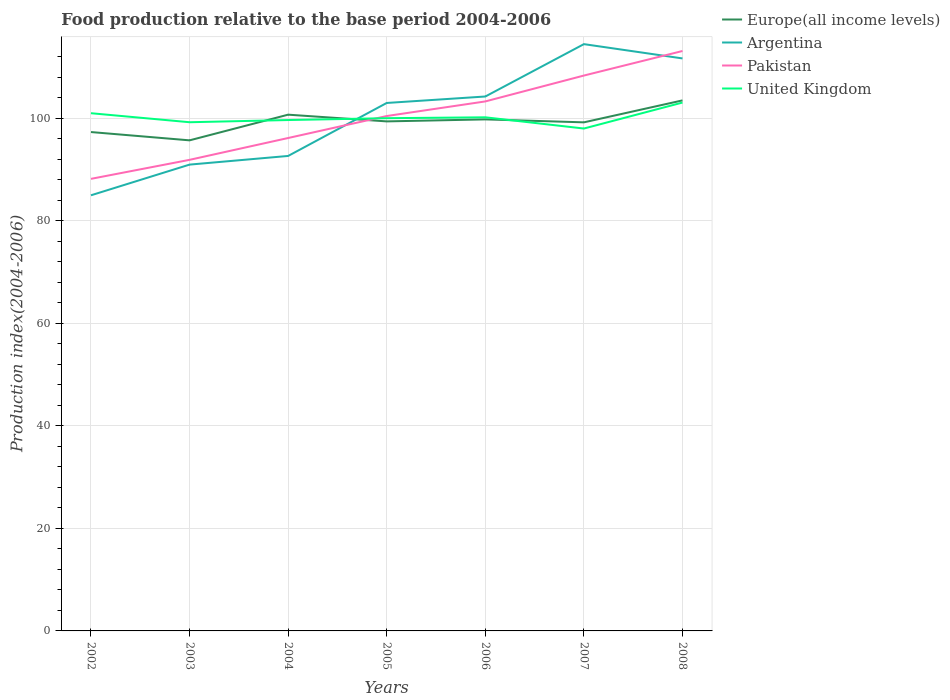How many different coloured lines are there?
Your answer should be compact. 4. Does the line corresponding to Argentina intersect with the line corresponding to United Kingdom?
Provide a succinct answer. Yes. Across all years, what is the maximum food production index in Argentina?
Offer a terse response. 85.01. In which year was the food production index in Europe(all income levels) maximum?
Provide a short and direct response. 2003. What is the total food production index in Pakistan in the graph?
Give a very brief answer. -11.4. What is the difference between the highest and the second highest food production index in Pakistan?
Keep it short and to the point. 24.95. What is the difference between the highest and the lowest food production index in Pakistan?
Make the answer very short. 4. How many lines are there?
Keep it short and to the point. 4. Are the values on the major ticks of Y-axis written in scientific E-notation?
Keep it short and to the point. No. Does the graph contain grids?
Keep it short and to the point. Yes. What is the title of the graph?
Keep it short and to the point. Food production relative to the base period 2004-2006. Does "Peru" appear as one of the legend labels in the graph?
Ensure brevity in your answer.  No. What is the label or title of the X-axis?
Give a very brief answer. Years. What is the label or title of the Y-axis?
Ensure brevity in your answer.  Production index(2004-2006). What is the Production index(2004-2006) in Europe(all income levels) in 2002?
Keep it short and to the point. 97.35. What is the Production index(2004-2006) in Argentina in 2002?
Offer a terse response. 85.01. What is the Production index(2004-2006) of Pakistan in 2002?
Provide a short and direct response. 88.22. What is the Production index(2004-2006) of United Kingdom in 2002?
Your answer should be compact. 101.03. What is the Production index(2004-2006) in Europe(all income levels) in 2003?
Ensure brevity in your answer.  95.74. What is the Production index(2004-2006) of Argentina in 2003?
Your answer should be compact. 91. What is the Production index(2004-2006) of Pakistan in 2003?
Provide a short and direct response. 91.93. What is the Production index(2004-2006) in United Kingdom in 2003?
Your answer should be very brief. 99.27. What is the Production index(2004-2006) in Europe(all income levels) in 2004?
Make the answer very short. 100.75. What is the Production index(2004-2006) of Argentina in 2004?
Ensure brevity in your answer.  92.69. What is the Production index(2004-2006) in Pakistan in 2004?
Offer a terse response. 96.19. What is the Production index(2004-2006) in United Kingdom in 2004?
Make the answer very short. 99.7. What is the Production index(2004-2006) of Europe(all income levels) in 2005?
Make the answer very short. 99.43. What is the Production index(2004-2006) of Argentina in 2005?
Your answer should be compact. 103.03. What is the Production index(2004-2006) of Pakistan in 2005?
Offer a terse response. 100.48. What is the Production index(2004-2006) of United Kingdom in 2005?
Offer a terse response. 100.06. What is the Production index(2004-2006) in Europe(all income levels) in 2006?
Provide a short and direct response. 99.82. What is the Production index(2004-2006) of Argentina in 2006?
Give a very brief answer. 104.29. What is the Production index(2004-2006) of Pakistan in 2006?
Your response must be concise. 103.33. What is the Production index(2004-2006) of United Kingdom in 2006?
Keep it short and to the point. 100.23. What is the Production index(2004-2006) in Europe(all income levels) in 2007?
Make the answer very short. 99.25. What is the Production index(2004-2006) of Argentina in 2007?
Offer a very short reply. 114.51. What is the Production index(2004-2006) of Pakistan in 2007?
Provide a succinct answer. 108.38. What is the Production index(2004-2006) in United Kingdom in 2007?
Your answer should be very brief. 98.04. What is the Production index(2004-2006) of Europe(all income levels) in 2008?
Offer a very short reply. 103.53. What is the Production index(2004-2006) of Argentina in 2008?
Give a very brief answer. 111.72. What is the Production index(2004-2006) of Pakistan in 2008?
Keep it short and to the point. 113.17. What is the Production index(2004-2006) of United Kingdom in 2008?
Ensure brevity in your answer.  103.11. Across all years, what is the maximum Production index(2004-2006) of Europe(all income levels)?
Make the answer very short. 103.53. Across all years, what is the maximum Production index(2004-2006) in Argentina?
Provide a short and direct response. 114.51. Across all years, what is the maximum Production index(2004-2006) of Pakistan?
Your answer should be compact. 113.17. Across all years, what is the maximum Production index(2004-2006) of United Kingdom?
Provide a short and direct response. 103.11. Across all years, what is the minimum Production index(2004-2006) in Europe(all income levels)?
Your response must be concise. 95.74. Across all years, what is the minimum Production index(2004-2006) of Argentina?
Provide a succinct answer. 85.01. Across all years, what is the minimum Production index(2004-2006) of Pakistan?
Your response must be concise. 88.22. Across all years, what is the minimum Production index(2004-2006) of United Kingdom?
Ensure brevity in your answer.  98.04. What is the total Production index(2004-2006) in Europe(all income levels) in the graph?
Your response must be concise. 695.87. What is the total Production index(2004-2006) in Argentina in the graph?
Give a very brief answer. 702.25. What is the total Production index(2004-2006) of Pakistan in the graph?
Make the answer very short. 701.7. What is the total Production index(2004-2006) in United Kingdom in the graph?
Provide a succinct answer. 701.44. What is the difference between the Production index(2004-2006) of Europe(all income levels) in 2002 and that in 2003?
Your answer should be compact. 1.62. What is the difference between the Production index(2004-2006) of Argentina in 2002 and that in 2003?
Offer a very short reply. -5.99. What is the difference between the Production index(2004-2006) of Pakistan in 2002 and that in 2003?
Your answer should be compact. -3.71. What is the difference between the Production index(2004-2006) in United Kingdom in 2002 and that in 2003?
Make the answer very short. 1.76. What is the difference between the Production index(2004-2006) of Europe(all income levels) in 2002 and that in 2004?
Provide a succinct answer. -3.39. What is the difference between the Production index(2004-2006) in Argentina in 2002 and that in 2004?
Give a very brief answer. -7.68. What is the difference between the Production index(2004-2006) in Pakistan in 2002 and that in 2004?
Offer a very short reply. -7.97. What is the difference between the Production index(2004-2006) in United Kingdom in 2002 and that in 2004?
Keep it short and to the point. 1.33. What is the difference between the Production index(2004-2006) in Europe(all income levels) in 2002 and that in 2005?
Your response must be concise. -2.08. What is the difference between the Production index(2004-2006) of Argentina in 2002 and that in 2005?
Your answer should be compact. -18.02. What is the difference between the Production index(2004-2006) of Pakistan in 2002 and that in 2005?
Ensure brevity in your answer.  -12.26. What is the difference between the Production index(2004-2006) of United Kingdom in 2002 and that in 2005?
Provide a succinct answer. 0.97. What is the difference between the Production index(2004-2006) in Europe(all income levels) in 2002 and that in 2006?
Offer a terse response. -2.47. What is the difference between the Production index(2004-2006) of Argentina in 2002 and that in 2006?
Give a very brief answer. -19.28. What is the difference between the Production index(2004-2006) of Pakistan in 2002 and that in 2006?
Keep it short and to the point. -15.11. What is the difference between the Production index(2004-2006) of Europe(all income levels) in 2002 and that in 2007?
Offer a terse response. -1.9. What is the difference between the Production index(2004-2006) of Argentina in 2002 and that in 2007?
Your answer should be compact. -29.5. What is the difference between the Production index(2004-2006) in Pakistan in 2002 and that in 2007?
Offer a terse response. -20.16. What is the difference between the Production index(2004-2006) of United Kingdom in 2002 and that in 2007?
Provide a succinct answer. 2.99. What is the difference between the Production index(2004-2006) in Europe(all income levels) in 2002 and that in 2008?
Provide a succinct answer. -6.18. What is the difference between the Production index(2004-2006) of Argentina in 2002 and that in 2008?
Offer a terse response. -26.71. What is the difference between the Production index(2004-2006) in Pakistan in 2002 and that in 2008?
Your answer should be very brief. -24.95. What is the difference between the Production index(2004-2006) of United Kingdom in 2002 and that in 2008?
Offer a terse response. -2.08. What is the difference between the Production index(2004-2006) of Europe(all income levels) in 2003 and that in 2004?
Offer a very short reply. -5.01. What is the difference between the Production index(2004-2006) of Argentina in 2003 and that in 2004?
Offer a terse response. -1.69. What is the difference between the Production index(2004-2006) of Pakistan in 2003 and that in 2004?
Your answer should be compact. -4.26. What is the difference between the Production index(2004-2006) of United Kingdom in 2003 and that in 2004?
Offer a terse response. -0.43. What is the difference between the Production index(2004-2006) in Europe(all income levels) in 2003 and that in 2005?
Keep it short and to the point. -3.7. What is the difference between the Production index(2004-2006) of Argentina in 2003 and that in 2005?
Provide a short and direct response. -12.03. What is the difference between the Production index(2004-2006) in Pakistan in 2003 and that in 2005?
Provide a short and direct response. -8.55. What is the difference between the Production index(2004-2006) of United Kingdom in 2003 and that in 2005?
Your answer should be compact. -0.79. What is the difference between the Production index(2004-2006) of Europe(all income levels) in 2003 and that in 2006?
Your answer should be very brief. -4.09. What is the difference between the Production index(2004-2006) of Argentina in 2003 and that in 2006?
Ensure brevity in your answer.  -13.29. What is the difference between the Production index(2004-2006) of Pakistan in 2003 and that in 2006?
Your response must be concise. -11.4. What is the difference between the Production index(2004-2006) in United Kingdom in 2003 and that in 2006?
Provide a short and direct response. -0.96. What is the difference between the Production index(2004-2006) in Europe(all income levels) in 2003 and that in 2007?
Offer a terse response. -3.51. What is the difference between the Production index(2004-2006) in Argentina in 2003 and that in 2007?
Provide a succinct answer. -23.51. What is the difference between the Production index(2004-2006) in Pakistan in 2003 and that in 2007?
Make the answer very short. -16.45. What is the difference between the Production index(2004-2006) in United Kingdom in 2003 and that in 2007?
Your response must be concise. 1.23. What is the difference between the Production index(2004-2006) in Europe(all income levels) in 2003 and that in 2008?
Your answer should be very brief. -7.8. What is the difference between the Production index(2004-2006) of Argentina in 2003 and that in 2008?
Provide a short and direct response. -20.72. What is the difference between the Production index(2004-2006) of Pakistan in 2003 and that in 2008?
Make the answer very short. -21.24. What is the difference between the Production index(2004-2006) in United Kingdom in 2003 and that in 2008?
Provide a short and direct response. -3.84. What is the difference between the Production index(2004-2006) of Europe(all income levels) in 2004 and that in 2005?
Make the answer very short. 1.31. What is the difference between the Production index(2004-2006) of Argentina in 2004 and that in 2005?
Make the answer very short. -10.34. What is the difference between the Production index(2004-2006) of Pakistan in 2004 and that in 2005?
Give a very brief answer. -4.29. What is the difference between the Production index(2004-2006) in United Kingdom in 2004 and that in 2005?
Your response must be concise. -0.36. What is the difference between the Production index(2004-2006) in Europe(all income levels) in 2004 and that in 2006?
Your answer should be very brief. 0.92. What is the difference between the Production index(2004-2006) of Argentina in 2004 and that in 2006?
Provide a succinct answer. -11.6. What is the difference between the Production index(2004-2006) in Pakistan in 2004 and that in 2006?
Keep it short and to the point. -7.14. What is the difference between the Production index(2004-2006) in United Kingdom in 2004 and that in 2006?
Provide a short and direct response. -0.53. What is the difference between the Production index(2004-2006) of Europe(all income levels) in 2004 and that in 2007?
Your answer should be compact. 1.5. What is the difference between the Production index(2004-2006) of Argentina in 2004 and that in 2007?
Offer a very short reply. -21.82. What is the difference between the Production index(2004-2006) of Pakistan in 2004 and that in 2007?
Offer a terse response. -12.19. What is the difference between the Production index(2004-2006) in United Kingdom in 2004 and that in 2007?
Provide a short and direct response. 1.66. What is the difference between the Production index(2004-2006) of Europe(all income levels) in 2004 and that in 2008?
Your answer should be compact. -2.79. What is the difference between the Production index(2004-2006) in Argentina in 2004 and that in 2008?
Offer a terse response. -19.03. What is the difference between the Production index(2004-2006) in Pakistan in 2004 and that in 2008?
Offer a terse response. -16.98. What is the difference between the Production index(2004-2006) of United Kingdom in 2004 and that in 2008?
Your response must be concise. -3.41. What is the difference between the Production index(2004-2006) of Europe(all income levels) in 2005 and that in 2006?
Provide a short and direct response. -0.39. What is the difference between the Production index(2004-2006) in Argentina in 2005 and that in 2006?
Make the answer very short. -1.26. What is the difference between the Production index(2004-2006) in Pakistan in 2005 and that in 2006?
Ensure brevity in your answer.  -2.85. What is the difference between the Production index(2004-2006) of United Kingdom in 2005 and that in 2006?
Your answer should be very brief. -0.17. What is the difference between the Production index(2004-2006) of Europe(all income levels) in 2005 and that in 2007?
Give a very brief answer. 0.19. What is the difference between the Production index(2004-2006) in Argentina in 2005 and that in 2007?
Provide a short and direct response. -11.48. What is the difference between the Production index(2004-2006) of Pakistan in 2005 and that in 2007?
Your answer should be compact. -7.9. What is the difference between the Production index(2004-2006) of United Kingdom in 2005 and that in 2007?
Your response must be concise. 2.02. What is the difference between the Production index(2004-2006) in Europe(all income levels) in 2005 and that in 2008?
Offer a terse response. -4.1. What is the difference between the Production index(2004-2006) in Argentina in 2005 and that in 2008?
Make the answer very short. -8.69. What is the difference between the Production index(2004-2006) of Pakistan in 2005 and that in 2008?
Your response must be concise. -12.69. What is the difference between the Production index(2004-2006) of United Kingdom in 2005 and that in 2008?
Offer a very short reply. -3.05. What is the difference between the Production index(2004-2006) in Europe(all income levels) in 2006 and that in 2007?
Your answer should be very brief. 0.57. What is the difference between the Production index(2004-2006) of Argentina in 2006 and that in 2007?
Keep it short and to the point. -10.22. What is the difference between the Production index(2004-2006) in Pakistan in 2006 and that in 2007?
Offer a terse response. -5.05. What is the difference between the Production index(2004-2006) of United Kingdom in 2006 and that in 2007?
Your answer should be compact. 2.19. What is the difference between the Production index(2004-2006) of Europe(all income levels) in 2006 and that in 2008?
Provide a short and direct response. -3.71. What is the difference between the Production index(2004-2006) of Argentina in 2006 and that in 2008?
Offer a very short reply. -7.43. What is the difference between the Production index(2004-2006) in Pakistan in 2006 and that in 2008?
Keep it short and to the point. -9.84. What is the difference between the Production index(2004-2006) in United Kingdom in 2006 and that in 2008?
Offer a very short reply. -2.88. What is the difference between the Production index(2004-2006) of Europe(all income levels) in 2007 and that in 2008?
Ensure brevity in your answer.  -4.28. What is the difference between the Production index(2004-2006) of Argentina in 2007 and that in 2008?
Keep it short and to the point. 2.79. What is the difference between the Production index(2004-2006) in Pakistan in 2007 and that in 2008?
Offer a very short reply. -4.79. What is the difference between the Production index(2004-2006) of United Kingdom in 2007 and that in 2008?
Keep it short and to the point. -5.07. What is the difference between the Production index(2004-2006) of Europe(all income levels) in 2002 and the Production index(2004-2006) of Argentina in 2003?
Keep it short and to the point. 6.35. What is the difference between the Production index(2004-2006) in Europe(all income levels) in 2002 and the Production index(2004-2006) in Pakistan in 2003?
Offer a very short reply. 5.42. What is the difference between the Production index(2004-2006) in Europe(all income levels) in 2002 and the Production index(2004-2006) in United Kingdom in 2003?
Offer a very short reply. -1.92. What is the difference between the Production index(2004-2006) of Argentina in 2002 and the Production index(2004-2006) of Pakistan in 2003?
Offer a terse response. -6.92. What is the difference between the Production index(2004-2006) of Argentina in 2002 and the Production index(2004-2006) of United Kingdom in 2003?
Offer a very short reply. -14.26. What is the difference between the Production index(2004-2006) in Pakistan in 2002 and the Production index(2004-2006) in United Kingdom in 2003?
Your response must be concise. -11.05. What is the difference between the Production index(2004-2006) of Europe(all income levels) in 2002 and the Production index(2004-2006) of Argentina in 2004?
Make the answer very short. 4.66. What is the difference between the Production index(2004-2006) of Europe(all income levels) in 2002 and the Production index(2004-2006) of Pakistan in 2004?
Provide a short and direct response. 1.16. What is the difference between the Production index(2004-2006) in Europe(all income levels) in 2002 and the Production index(2004-2006) in United Kingdom in 2004?
Give a very brief answer. -2.35. What is the difference between the Production index(2004-2006) in Argentina in 2002 and the Production index(2004-2006) in Pakistan in 2004?
Your answer should be very brief. -11.18. What is the difference between the Production index(2004-2006) in Argentina in 2002 and the Production index(2004-2006) in United Kingdom in 2004?
Offer a very short reply. -14.69. What is the difference between the Production index(2004-2006) of Pakistan in 2002 and the Production index(2004-2006) of United Kingdom in 2004?
Your answer should be very brief. -11.48. What is the difference between the Production index(2004-2006) in Europe(all income levels) in 2002 and the Production index(2004-2006) in Argentina in 2005?
Your response must be concise. -5.68. What is the difference between the Production index(2004-2006) of Europe(all income levels) in 2002 and the Production index(2004-2006) of Pakistan in 2005?
Your response must be concise. -3.13. What is the difference between the Production index(2004-2006) of Europe(all income levels) in 2002 and the Production index(2004-2006) of United Kingdom in 2005?
Offer a very short reply. -2.71. What is the difference between the Production index(2004-2006) of Argentina in 2002 and the Production index(2004-2006) of Pakistan in 2005?
Give a very brief answer. -15.47. What is the difference between the Production index(2004-2006) in Argentina in 2002 and the Production index(2004-2006) in United Kingdom in 2005?
Your answer should be compact. -15.05. What is the difference between the Production index(2004-2006) in Pakistan in 2002 and the Production index(2004-2006) in United Kingdom in 2005?
Your answer should be very brief. -11.84. What is the difference between the Production index(2004-2006) in Europe(all income levels) in 2002 and the Production index(2004-2006) in Argentina in 2006?
Offer a terse response. -6.94. What is the difference between the Production index(2004-2006) of Europe(all income levels) in 2002 and the Production index(2004-2006) of Pakistan in 2006?
Give a very brief answer. -5.98. What is the difference between the Production index(2004-2006) in Europe(all income levels) in 2002 and the Production index(2004-2006) in United Kingdom in 2006?
Make the answer very short. -2.88. What is the difference between the Production index(2004-2006) in Argentina in 2002 and the Production index(2004-2006) in Pakistan in 2006?
Offer a very short reply. -18.32. What is the difference between the Production index(2004-2006) in Argentina in 2002 and the Production index(2004-2006) in United Kingdom in 2006?
Your response must be concise. -15.22. What is the difference between the Production index(2004-2006) in Pakistan in 2002 and the Production index(2004-2006) in United Kingdom in 2006?
Provide a short and direct response. -12.01. What is the difference between the Production index(2004-2006) in Europe(all income levels) in 2002 and the Production index(2004-2006) in Argentina in 2007?
Ensure brevity in your answer.  -17.16. What is the difference between the Production index(2004-2006) of Europe(all income levels) in 2002 and the Production index(2004-2006) of Pakistan in 2007?
Ensure brevity in your answer.  -11.03. What is the difference between the Production index(2004-2006) of Europe(all income levels) in 2002 and the Production index(2004-2006) of United Kingdom in 2007?
Give a very brief answer. -0.69. What is the difference between the Production index(2004-2006) of Argentina in 2002 and the Production index(2004-2006) of Pakistan in 2007?
Provide a succinct answer. -23.37. What is the difference between the Production index(2004-2006) in Argentina in 2002 and the Production index(2004-2006) in United Kingdom in 2007?
Keep it short and to the point. -13.03. What is the difference between the Production index(2004-2006) of Pakistan in 2002 and the Production index(2004-2006) of United Kingdom in 2007?
Ensure brevity in your answer.  -9.82. What is the difference between the Production index(2004-2006) of Europe(all income levels) in 2002 and the Production index(2004-2006) of Argentina in 2008?
Your answer should be very brief. -14.37. What is the difference between the Production index(2004-2006) of Europe(all income levels) in 2002 and the Production index(2004-2006) of Pakistan in 2008?
Keep it short and to the point. -15.82. What is the difference between the Production index(2004-2006) of Europe(all income levels) in 2002 and the Production index(2004-2006) of United Kingdom in 2008?
Make the answer very short. -5.76. What is the difference between the Production index(2004-2006) of Argentina in 2002 and the Production index(2004-2006) of Pakistan in 2008?
Keep it short and to the point. -28.16. What is the difference between the Production index(2004-2006) of Argentina in 2002 and the Production index(2004-2006) of United Kingdom in 2008?
Provide a short and direct response. -18.1. What is the difference between the Production index(2004-2006) in Pakistan in 2002 and the Production index(2004-2006) in United Kingdom in 2008?
Offer a terse response. -14.89. What is the difference between the Production index(2004-2006) of Europe(all income levels) in 2003 and the Production index(2004-2006) of Argentina in 2004?
Ensure brevity in your answer.  3.05. What is the difference between the Production index(2004-2006) of Europe(all income levels) in 2003 and the Production index(2004-2006) of Pakistan in 2004?
Make the answer very short. -0.45. What is the difference between the Production index(2004-2006) in Europe(all income levels) in 2003 and the Production index(2004-2006) in United Kingdom in 2004?
Your answer should be compact. -3.96. What is the difference between the Production index(2004-2006) of Argentina in 2003 and the Production index(2004-2006) of Pakistan in 2004?
Your answer should be compact. -5.19. What is the difference between the Production index(2004-2006) of Pakistan in 2003 and the Production index(2004-2006) of United Kingdom in 2004?
Offer a terse response. -7.77. What is the difference between the Production index(2004-2006) of Europe(all income levels) in 2003 and the Production index(2004-2006) of Argentina in 2005?
Your response must be concise. -7.29. What is the difference between the Production index(2004-2006) of Europe(all income levels) in 2003 and the Production index(2004-2006) of Pakistan in 2005?
Your answer should be very brief. -4.74. What is the difference between the Production index(2004-2006) of Europe(all income levels) in 2003 and the Production index(2004-2006) of United Kingdom in 2005?
Your answer should be compact. -4.32. What is the difference between the Production index(2004-2006) of Argentina in 2003 and the Production index(2004-2006) of Pakistan in 2005?
Your response must be concise. -9.48. What is the difference between the Production index(2004-2006) in Argentina in 2003 and the Production index(2004-2006) in United Kingdom in 2005?
Make the answer very short. -9.06. What is the difference between the Production index(2004-2006) of Pakistan in 2003 and the Production index(2004-2006) of United Kingdom in 2005?
Provide a succinct answer. -8.13. What is the difference between the Production index(2004-2006) in Europe(all income levels) in 2003 and the Production index(2004-2006) in Argentina in 2006?
Give a very brief answer. -8.55. What is the difference between the Production index(2004-2006) of Europe(all income levels) in 2003 and the Production index(2004-2006) of Pakistan in 2006?
Provide a succinct answer. -7.59. What is the difference between the Production index(2004-2006) in Europe(all income levels) in 2003 and the Production index(2004-2006) in United Kingdom in 2006?
Keep it short and to the point. -4.49. What is the difference between the Production index(2004-2006) in Argentina in 2003 and the Production index(2004-2006) in Pakistan in 2006?
Offer a very short reply. -12.33. What is the difference between the Production index(2004-2006) in Argentina in 2003 and the Production index(2004-2006) in United Kingdom in 2006?
Provide a succinct answer. -9.23. What is the difference between the Production index(2004-2006) of Europe(all income levels) in 2003 and the Production index(2004-2006) of Argentina in 2007?
Your answer should be compact. -18.77. What is the difference between the Production index(2004-2006) in Europe(all income levels) in 2003 and the Production index(2004-2006) in Pakistan in 2007?
Your answer should be compact. -12.64. What is the difference between the Production index(2004-2006) in Europe(all income levels) in 2003 and the Production index(2004-2006) in United Kingdom in 2007?
Your answer should be very brief. -2.3. What is the difference between the Production index(2004-2006) of Argentina in 2003 and the Production index(2004-2006) of Pakistan in 2007?
Offer a very short reply. -17.38. What is the difference between the Production index(2004-2006) in Argentina in 2003 and the Production index(2004-2006) in United Kingdom in 2007?
Your answer should be very brief. -7.04. What is the difference between the Production index(2004-2006) of Pakistan in 2003 and the Production index(2004-2006) of United Kingdom in 2007?
Offer a terse response. -6.11. What is the difference between the Production index(2004-2006) in Europe(all income levels) in 2003 and the Production index(2004-2006) in Argentina in 2008?
Make the answer very short. -15.98. What is the difference between the Production index(2004-2006) in Europe(all income levels) in 2003 and the Production index(2004-2006) in Pakistan in 2008?
Offer a very short reply. -17.43. What is the difference between the Production index(2004-2006) in Europe(all income levels) in 2003 and the Production index(2004-2006) in United Kingdom in 2008?
Your response must be concise. -7.37. What is the difference between the Production index(2004-2006) of Argentina in 2003 and the Production index(2004-2006) of Pakistan in 2008?
Ensure brevity in your answer.  -22.17. What is the difference between the Production index(2004-2006) of Argentina in 2003 and the Production index(2004-2006) of United Kingdom in 2008?
Give a very brief answer. -12.11. What is the difference between the Production index(2004-2006) in Pakistan in 2003 and the Production index(2004-2006) in United Kingdom in 2008?
Give a very brief answer. -11.18. What is the difference between the Production index(2004-2006) of Europe(all income levels) in 2004 and the Production index(2004-2006) of Argentina in 2005?
Offer a terse response. -2.28. What is the difference between the Production index(2004-2006) of Europe(all income levels) in 2004 and the Production index(2004-2006) of Pakistan in 2005?
Offer a very short reply. 0.27. What is the difference between the Production index(2004-2006) of Europe(all income levels) in 2004 and the Production index(2004-2006) of United Kingdom in 2005?
Give a very brief answer. 0.69. What is the difference between the Production index(2004-2006) of Argentina in 2004 and the Production index(2004-2006) of Pakistan in 2005?
Ensure brevity in your answer.  -7.79. What is the difference between the Production index(2004-2006) in Argentina in 2004 and the Production index(2004-2006) in United Kingdom in 2005?
Your response must be concise. -7.37. What is the difference between the Production index(2004-2006) of Pakistan in 2004 and the Production index(2004-2006) of United Kingdom in 2005?
Provide a succinct answer. -3.87. What is the difference between the Production index(2004-2006) in Europe(all income levels) in 2004 and the Production index(2004-2006) in Argentina in 2006?
Provide a succinct answer. -3.54. What is the difference between the Production index(2004-2006) in Europe(all income levels) in 2004 and the Production index(2004-2006) in Pakistan in 2006?
Keep it short and to the point. -2.58. What is the difference between the Production index(2004-2006) in Europe(all income levels) in 2004 and the Production index(2004-2006) in United Kingdom in 2006?
Offer a terse response. 0.52. What is the difference between the Production index(2004-2006) in Argentina in 2004 and the Production index(2004-2006) in Pakistan in 2006?
Provide a short and direct response. -10.64. What is the difference between the Production index(2004-2006) of Argentina in 2004 and the Production index(2004-2006) of United Kingdom in 2006?
Give a very brief answer. -7.54. What is the difference between the Production index(2004-2006) of Pakistan in 2004 and the Production index(2004-2006) of United Kingdom in 2006?
Make the answer very short. -4.04. What is the difference between the Production index(2004-2006) of Europe(all income levels) in 2004 and the Production index(2004-2006) of Argentina in 2007?
Make the answer very short. -13.76. What is the difference between the Production index(2004-2006) in Europe(all income levels) in 2004 and the Production index(2004-2006) in Pakistan in 2007?
Your response must be concise. -7.63. What is the difference between the Production index(2004-2006) of Europe(all income levels) in 2004 and the Production index(2004-2006) of United Kingdom in 2007?
Your answer should be compact. 2.71. What is the difference between the Production index(2004-2006) in Argentina in 2004 and the Production index(2004-2006) in Pakistan in 2007?
Provide a succinct answer. -15.69. What is the difference between the Production index(2004-2006) in Argentina in 2004 and the Production index(2004-2006) in United Kingdom in 2007?
Your answer should be compact. -5.35. What is the difference between the Production index(2004-2006) of Pakistan in 2004 and the Production index(2004-2006) of United Kingdom in 2007?
Make the answer very short. -1.85. What is the difference between the Production index(2004-2006) in Europe(all income levels) in 2004 and the Production index(2004-2006) in Argentina in 2008?
Your answer should be very brief. -10.97. What is the difference between the Production index(2004-2006) of Europe(all income levels) in 2004 and the Production index(2004-2006) of Pakistan in 2008?
Your answer should be very brief. -12.42. What is the difference between the Production index(2004-2006) of Europe(all income levels) in 2004 and the Production index(2004-2006) of United Kingdom in 2008?
Provide a succinct answer. -2.36. What is the difference between the Production index(2004-2006) in Argentina in 2004 and the Production index(2004-2006) in Pakistan in 2008?
Make the answer very short. -20.48. What is the difference between the Production index(2004-2006) of Argentina in 2004 and the Production index(2004-2006) of United Kingdom in 2008?
Provide a short and direct response. -10.42. What is the difference between the Production index(2004-2006) in Pakistan in 2004 and the Production index(2004-2006) in United Kingdom in 2008?
Offer a very short reply. -6.92. What is the difference between the Production index(2004-2006) of Europe(all income levels) in 2005 and the Production index(2004-2006) of Argentina in 2006?
Give a very brief answer. -4.86. What is the difference between the Production index(2004-2006) in Europe(all income levels) in 2005 and the Production index(2004-2006) in Pakistan in 2006?
Ensure brevity in your answer.  -3.9. What is the difference between the Production index(2004-2006) of Europe(all income levels) in 2005 and the Production index(2004-2006) of United Kingdom in 2006?
Ensure brevity in your answer.  -0.8. What is the difference between the Production index(2004-2006) in Argentina in 2005 and the Production index(2004-2006) in Pakistan in 2006?
Your answer should be very brief. -0.3. What is the difference between the Production index(2004-2006) in Europe(all income levels) in 2005 and the Production index(2004-2006) in Argentina in 2007?
Your answer should be compact. -15.08. What is the difference between the Production index(2004-2006) in Europe(all income levels) in 2005 and the Production index(2004-2006) in Pakistan in 2007?
Keep it short and to the point. -8.95. What is the difference between the Production index(2004-2006) of Europe(all income levels) in 2005 and the Production index(2004-2006) of United Kingdom in 2007?
Provide a succinct answer. 1.39. What is the difference between the Production index(2004-2006) of Argentina in 2005 and the Production index(2004-2006) of Pakistan in 2007?
Give a very brief answer. -5.35. What is the difference between the Production index(2004-2006) in Argentina in 2005 and the Production index(2004-2006) in United Kingdom in 2007?
Offer a terse response. 4.99. What is the difference between the Production index(2004-2006) in Pakistan in 2005 and the Production index(2004-2006) in United Kingdom in 2007?
Make the answer very short. 2.44. What is the difference between the Production index(2004-2006) in Europe(all income levels) in 2005 and the Production index(2004-2006) in Argentina in 2008?
Your answer should be very brief. -12.29. What is the difference between the Production index(2004-2006) in Europe(all income levels) in 2005 and the Production index(2004-2006) in Pakistan in 2008?
Offer a very short reply. -13.74. What is the difference between the Production index(2004-2006) in Europe(all income levels) in 2005 and the Production index(2004-2006) in United Kingdom in 2008?
Your response must be concise. -3.68. What is the difference between the Production index(2004-2006) of Argentina in 2005 and the Production index(2004-2006) of Pakistan in 2008?
Your answer should be compact. -10.14. What is the difference between the Production index(2004-2006) in Argentina in 2005 and the Production index(2004-2006) in United Kingdom in 2008?
Offer a very short reply. -0.08. What is the difference between the Production index(2004-2006) in Pakistan in 2005 and the Production index(2004-2006) in United Kingdom in 2008?
Offer a terse response. -2.63. What is the difference between the Production index(2004-2006) of Europe(all income levels) in 2006 and the Production index(2004-2006) of Argentina in 2007?
Offer a terse response. -14.69. What is the difference between the Production index(2004-2006) in Europe(all income levels) in 2006 and the Production index(2004-2006) in Pakistan in 2007?
Provide a succinct answer. -8.56. What is the difference between the Production index(2004-2006) of Europe(all income levels) in 2006 and the Production index(2004-2006) of United Kingdom in 2007?
Your response must be concise. 1.78. What is the difference between the Production index(2004-2006) of Argentina in 2006 and the Production index(2004-2006) of Pakistan in 2007?
Ensure brevity in your answer.  -4.09. What is the difference between the Production index(2004-2006) in Argentina in 2006 and the Production index(2004-2006) in United Kingdom in 2007?
Your answer should be compact. 6.25. What is the difference between the Production index(2004-2006) in Pakistan in 2006 and the Production index(2004-2006) in United Kingdom in 2007?
Offer a very short reply. 5.29. What is the difference between the Production index(2004-2006) of Europe(all income levels) in 2006 and the Production index(2004-2006) of Argentina in 2008?
Give a very brief answer. -11.9. What is the difference between the Production index(2004-2006) in Europe(all income levels) in 2006 and the Production index(2004-2006) in Pakistan in 2008?
Your answer should be compact. -13.35. What is the difference between the Production index(2004-2006) of Europe(all income levels) in 2006 and the Production index(2004-2006) of United Kingdom in 2008?
Ensure brevity in your answer.  -3.29. What is the difference between the Production index(2004-2006) in Argentina in 2006 and the Production index(2004-2006) in Pakistan in 2008?
Provide a short and direct response. -8.88. What is the difference between the Production index(2004-2006) of Argentina in 2006 and the Production index(2004-2006) of United Kingdom in 2008?
Provide a succinct answer. 1.18. What is the difference between the Production index(2004-2006) in Pakistan in 2006 and the Production index(2004-2006) in United Kingdom in 2008?
Provide a succinct answer. 0.22. What is the difference between the Production index(2004-2006) in Europe(all income levels) in 2007 and the Production index(2004-2006) in Argentina in 2008?
Offer a very short reply. -12.47. What is the difference between the Production index(2004-2006) of Europe(all income levels) in 2007 and the Production index(2004-2006) of Pakistan in 2008?
Your answer should be very brief. -13.92. What is the difference between the Production index(2004-2006) of Europe(all income levels) in 2007 and the Production index(2004-2006) of United Kingdom in 2008?
Offer a terse response. -3.86. What is the difference between the Production index(2004-2006) of Argentina in 2007 and the Production index(2004-2006) of Pakistan in 2008?
Offer a terse response. 1.34. What is the difference between the Production index(2004-2006) in Pakistan in 2007 and the Production index(2004-2006) in United Kingdom in 2008?
Ensure brevity in your answer.  5.27. What is the average Production index(2004-2006) in Europe(all income levels) per year?
Offer a terse response. 99.41. What is the average Production index(2004-2006) of Argentina per year?
Offer a very short reply. 100.32. What is the average Production index(2004-2006) in Pakistan per year?
Ensure brevity in your answer.  100.24. What is the average Production index(2004-2006) in United Kingdom per year?
Your response must be concise. 100.21. In the year 2002, what is the difference between the Production index(2004-2006) of Europe(all income levels) and Production index(2004-2006) of Argentina?
Your answer should be compact. 12.34. In the year 2002, what is the difference between the Production index(2004-2006) in Europe(all income levels) and Production index(2004-2006) in Pakistan?
Ensure brevity in your answer.  9.13. In the year 2002, what is the difference between the Production index(2004-2006) in Europe(all income levels) and Production index(2004-2006) in United Kingdom?
Provide a succinct answer. -3.68. In the year 2002, what is the difference between the Production index(2004-2006) of Argentina and Production index(2004-2006) of Pakistan?
Ensure brevity in your answer.  -3.21. In the year 2002, what is the difference between the Production index(2004-2006) of Argentina and Production index(2004-2006) of United Kingdom?
Offer a terse response. -16.02. In the year 2002, what is the difference between the Production index(2004-2006) in Pakistan and Production index(2004-2006) in United Kingdom?
Your answer should be compact. -12.81. In the year 2003, what is the difference between the Production index(2004-2006) in Europe(all income levels) and Production index(2004-2006) in Argentina?
Keep it short and to the point. 4.74. In the year 2003, what is the difference between the Production index(2004-2006) in Europe(all income levels) and Production index(2004-2006) in Pakistan?
Offer a very short reply. 3.81. In the year 2003, what is the difference between the Production index(2004-2006) in Europe(all income levels) and Production index(2004-2006) in United Kingdom?
Provide a short and direct response. -3.53. In the year 2003, what is the difference between the Production index(2004-2006) of Argentina and Production index(2004-2006) of Pakistan?
Provide a short and direct response. -0.93. In the year 2003, what is the difference between the Production index(2004-2006) in Argentina and Production index(2004-2006) in United Kingdom?
Your answer should be compact. -8.27. In the year 2003, what is the difference between the Production index(2004-2006) in Pakistan and Production index(2004-2006) in United Kingdom?
Give a very brief answer. -7.34. In the year 2004, what is the difference between the Production index(2004-2006) in Europe(all income levels) and Production index(2004-2006) in Argentina?
Ensure brevity in your answer.  8.06. In the year 2004, what is the difference between the Production index(2004-2006) of Europe(all income levels) and Production index(2004-2006) of Pakistan?
Offer a very short reply. 4.56. In the year 2004, what is the difference between the Production index(2004-2006) in Europe(all income levels) and Production index(2004-2006) in United Kingdom?
Keep it short and to the point. 1.05. In the year 2004, what is the difference between the Production index(2004-2006) in Argentina and Production index(2004-2006) in Pakistan?
Your answer should be compact. -3.5. In the year 2004, what is the difference between the Production index(2004-2006) of Argentina and Production index(2004-2006) of United Kingdom?
Make the answer very short. -7.01. In the year 2004, what is the difference between the Production index(2004-2006) in Pakistan and Production index(2004-2006) in United Kingdom?
Offer a very short reply. -3.51. In the year 2005, what is the difference between the Production index(2004-2006) of Europe(all income levels) and Production index(2004-2006) of Argentina?
Your answer should be very brief. -3.6. In the year 2005, what is the difference between the Production index(2004-2006) in Europe(all income levels) and Production index(2004-2006) in Pakistan?
Ensure brevity in your answer.  -1.05. In the year 2005, what is the difference between the Production index(2004-2006) of Europe(all income levels) and Production index(2004-2006) of United Kingdom?
Give a very brief answer. -0.63. In the year 2005, what is the difference between the Production index(2004-2006) of Argentina and Production index(2004-2006) of Pakistan?
Ensure brevity in your answer.  2.55. In the year 2005, what is the difference between the Production index(2004-2006) of Argentina and Production index(2004-2006) of United Kingdom?
Make the answer very short. 2.97. In the year 2005, what is the difference between the Production index(2004-2006) in Pakistan and Production index(2004-2006) in United Kingdom?
Ensure brevity in your answer.  0.42. In the year 2006, what is the difference between the Production index(2004-2006) of Europe(all income levels) and Production index(2004-2006) of Argentina?
Provide a succinct answer. -4.47. In the year 2006, what is the difference between the Production index(2004-2006) in Europe(all income levels) and Production index(2004-2006) in Pakistan?
Your answer should be very brief. -3.51. In the year 2006, what is the difference between the Production index(2004-2006) in Europe(all income levels) and Production index(2004-2006) in United Kingdom?
Make the answer very short. -0.41. In the year 2006, what is the difference between the Production index(2004-2006) of Argentina and Production index(2004-2006) of United Kingdom?
Offer a very short reply. 4.06. In the year 2007, what is the difference between the Production index(2004-2006) of Europe(all income levels) and Production index(2004-2006) of Argentina?
Offer a very short reply. -15.26. In the year 2007, what is the difference between the Production index(2004-2006) in Europe(all income levels) and Production index(2004-2006) in Pakistan?
Offer a terse response. -9.13. In the year 2007, what is the difference between the Production index(2004-2006) of Europe(all income levels) and Production index(2004-2006) of United Kingdom?
Your answer should be compact. 1.21. In the year 2007, what is the difference between the Production index(2004-2006) of Argentina and Production index(2004-2006) of Pakistan?
Ensure brevity in your answer.  6.13. In the year 2007, what is the difference between the Production index(2004-2006) of Argentina and Production index(2004-2006) of United Kingdom?
Your answer should be very brief. 16.47. In the year 2007, what is the difference between the Production index(2004-2006) in Pakistan and Production index(2004-2006) in United Kingdom?
Ensure brevity in your answer.  10.34. In the year 2008, what is the difference between the Production index(2004-2006) of Europe(all income levels) and Production index(2004-2006) of Argentina?
Your answer should be compact. -8.19. In the year 2008, what is the difference between the Production index(2004-2006) of Europe(all income levels) and Production index(2004-2006) of Pakistan?
Ensure brevity in your answer.  -9.64. In the year 2008, what is the difference between the Production index(2004-2006) in Europe(all income levels) and Production index(2004-2006) in United Kingdom?
Your answer should be very brief. 0.42. In the year 2008, what is the difference between the Production index(2004-2006) of Argentina and Production index(2004-2006) of Pakistan?
Provide a short and direct response. -1.45. In the year 2008, what is the difference between the Production index(2004-2006) in Argentina and Production index(2004-2006) in United Kingdom?
Your response must be concise. 8.61. In the year 2008, what is the difference between the Production index(2004-2006) in Pakistan and Production index(2004-2006) in United Kingdom?
Provide a short and direct response. 10.06. What is the ratio of the Production index(2004-2006) of Europe(all income levels) in 2002 to that in 2003?
Provide a short and direct response. 1.02. What is the ratio of the Production index(2004-2006) of Argentina in 2002 to that in 2003?
Offer a terse response. 0.93. What is the ratio of the Production index(2004-2006) of Pakistan in 2002 to that in 2003?
Offer a very short reply. 0.96. What is the ratio of the Production index(2004-2006) in United Kingdom in 2002 to that in 2003?
Your response must be concise. 1.02. What is the ratio of the Production index(2004-2006) in Europe(all income levels) in 2002 to that in 2004?
Provide a short and direct response. 0.97. What is the ratio of the Production index(2004-2006) of Argentina in 2002 to that in 2004?
Offer a very short reply. 0.92. What is the ratio of the Production index(2004-2006) of Pakistan in 2002 to that in 2004?
Your answer should be very brief. 0.92. What is the ratio of the Production index(2004-2006) in United Kingdom in 2002 to that in 2004?
Your answer should be very brief. 1.01. What is the ratio of the Production index(2004-2006) of Europe(all income levels) in 2002 to that in 2005?
Ensure brevity in your answer.  0.98. What is the ratio of the Production index(2004-2006) of Argentina in 2002 to that in 2005?
Offer a terse response. 0.83. What is the ratio of the Production index(2004-2006) of Pakistan in 2002 to that in 2005?
Give a very brief answer. 0.88. What is the ratio of the Production index(2004-2006) in United Kingdom in 2002 to that in 2005?
Offer a terse response. 1.01. What is the ratio of the Production index(2004-2006) in Europe(all income levels) in 2002 to that in 2006?
Give a very brief answer. 0.98. What is the ratio of the Production index(2004-2006) of Argentina in 2002 to that in 2006?
Provide a short and direct response. 0.82. What is the ratio of the Production index(2004-2006) of Pakistan in 2002 to that in 2006?
Keep it short and to the point. 0.85. What is the ratio of the Production index(2004-2006) of United Kingdom in 2002 to that in 2006?
Your response must be concise. 1.01. What is the ratio of the Production index(2004-2006) in Europe(all income levels) in 2002 to that in 2007?
Your response must be concise. 0.98. What is the ratio of the Production index(2004-2006) in Argentina in 2002 to that in 2007?
Provide a succinct answer. 0.74. What is the ratio of the Production index(2004-2006) of Pakistan in 2002 to that in 2007?
Provide a succinct answer. 0.81. What is the ratio of the Production index(2004-2006) in United Kingdom in 2002 to that in 2007?
Ensure brevity in your answer.  1.03. What is the ratio of the Production index(2004-2006) in Europe(all income levels) in 2002 to that in 2008?
Offer a terse response. 0.94. What is the ratio of the Production index(2004-2006) in Argentina in 2002 to that in 2008?
Offer a very short reply. 0.76. What is the ratio of the Production index(2004-2006) in Pakistan in 2002 to that in 2008?
Keep it short and to the point. 0.78. What is the ratio of the Production index(2004-2006) of United Kingdom in 2002 to that in 2008?
Offer a terse response. 0.98. What is the ratio of the Production index(2004-2006) in Europe(all income levels) in 2003 to that in 2004?
Provide a succinct answer. 0.95. What is the ratio of the Production index(2004-2006) of Argentina in 2003 to that in 2004?
Make the answer very short. 0.98. What is the ratio of the Production index(2004-2006) in Pakistan in 2003 to that in 2004?
Your response must be concise. 0.96. What is the ratio of the Production index(2004-2006) of Europe(all income levels) in 2003 to that in 2005?
Offer a very short reply. 0.96. What is the ratio of the Production index(2004-2006) of Argentina in 2003 to that in 2005?
Your answer should be very brief. 0.88. What is the ratio of the Production index(2004-2006) in Pakistan in 2003 to that in 2005?
Ensure brevity in your answer.  0.91. What is the ratio of the Production index(2004-2006) in Europe(all income levels) in 2003 to that in 2006?
Provide a short and direct response. 0.96. What is the ratio of the Production index(2004-2006) in Argentina in 2003 to that in 2006?
Offer a terse response. 0.87. What is the ratio of the Production index(2004-2006) in Pakistan in 2003 to that in 2006?
Offer a very short reply. 0.89. What is the ratio of the Production index(2004-2006) in Europe(all income levels) in 2003 to that in 2007?
Provide a short and direct response. 0.96. What is the ratio of the Production index(2004-2006) in Argentina in 2003 to that in 2007?
Ensure brevity in your answer.  0.79. What is the ratio of the Production index(2004-2006) of Pakistan in 2003 to that in 2007?
Your answer should be compact. 0.85. What is the ratio of the Production index(2004-2006) in United Kingdom in 2003 to that in 2007?
Ensure brevity in your answer.  1.01. What is the ratio of the Production index(2004-2006) of Europe(all income levels) in 2003 to that in 2008?
Make the answer very short. 0.92. What is the ratio of the Production index(2004-2006) in Argentina in 2003 to that in 2008?
Give a very brief answer. 0.81. What is the ratio of the Production index(2004-2006) of Pakistan in 2003 to that in 2008?
Make the answer very short. 0.81. What is the ratio of the Production index(2004-2006) in United Kingdom in 2003 to that in 2008?
Offer a terse response. 0.96. What is the ratio of the Production index(2004-2006) in Europe(all income levels) in 2004 to that in 2005?
Provide a short and direct response. 1.01. What is the ratio of the Production index(2004-2006) of Argentina in 2004 to that in 2005?
Offer a terse response. 0.9. What is the ratio of the Production index(2004-2006) in Pakistan in 2004 to that in 2005?
Give a very brief answer. 0.96. What is the ratio of the Production index(2004-2006) in United Kingdom in 2004 to that in 2005?
Ensure brevity in your answer.  1. What is the ratio of the Production index(2004-2006) of Europe(all income levels) in 2004 to that in 2006?
Ensure brevity in your answer.  1.01. What is the ratio of the Production index(2004-2006) of Argentina in 2004 to that in 2006?
Ensure brevity in your answer.  0.89. What is the ratio of the Production index(2004-2006) of Pakistan in 2004 to that in 2006?
Offer a terse response. 0.93. What is the ratio of the Production index(2004-2006) of United Kingdom in 2004 to that in 2006?
Provide a succinct answer. 0.99. What is the ratio of the Production index(2004-2006) of Europe(all income levels) in 2004 to that in 2007?
Your response must be concise. 1.02. What is the ratio of the Production index(2004-2006) of Argentina in 2004 to that in 2007?
Your answer should be compact. 0.81. What is the ratio of the Production index(2004-2006) in Pakistan in 2004 to that in 2007?
Ensure brevity in your answer.  0.89. What is the ratio of the Production index(2004-2006) of United Kingdom in 2004 to that in 2007?
Your answer should be very brief. 1.02. What is the ratio of the Production index(2004-2006) of Europe(all income levels) in 2004 to that in 2008?
Ensure brevity in your answer.  0.97. What is the ratio of the Production index(2004-2006) of Argentina in 2004 to that in 2008?
Make the answer very short. 0.83. What is the ratio of the Production index(2004-2006) in United Kingdom in 2004 to that in 2008?
Keep it short and to the point. 0.97. What is the ratio of the Production index(2004-2006) in Argentina in 2005 to that in 2006?
Provide a succinct answer. 0.99. What is the ratio of the Production index(2004-2006) in Pakistan in 2005 to that in 2006?
Your response must be concise. 0.97. What is the ratio of the Production index(2004-2006) in Argentina in 2005 to that in 2007?
Provide a short and direct response. 0.9. What is the ratio of the Production index(2004-2006) in Pakistan in 2005 to that in 2007?
Provide a short and direct response. 0.93. What is the ratio of the Production index(2004-2006) in United Kingdom in 2005 to that in 2007?
Your response must be concise. 1.02. What is the ratio of the Production index(2004-2006) of Europe(all income levels) in 2005 to that in 2008?
Offer a very short reply. 0.96. What is the ratio of the Production index(2004-2006) of Argentina in 2005 to that in 2008?
Provide a succinct answer. 0.92. What is the ratio of the Production index(2004-2006) in Pakistan in 2005 to that in 2008?
Make the answer very short. 0.89. What is the ratio of the Production index(2004-2006) in United Kingdom in 2005 to that in 2008?
Offer a very short reply. 0.97. What is the ratio of the Production index(2004-2006) in Europe(all income levels) in 2006 to that in 2007?
Give a very brief answer. 1.01. What is the ratio of the Production index(2004-2006) of Argentina in 2006 to that in 2007?
Your answer should be compact. 0.91. What is the ratio of the Production index(2004-2006) in Pakistan in 2006 to that in 2007?
Your answer should be compact. 0.95. What is the ratio of the Production index(2004-2006) in United Kingdom in 2006 to that in 2007?
Give a very brief answer. 1.02. What is the ratio of the Production index(2004-2006) in Europe(all income levels) in 2006 to that in 2008?
Ensure brevity in your answer.  0.96. What is the ratio of the Production index(2004-2006) in Argentina in 2006 to that in 2008?
Offer a terse response. 0.93. What is the ratio of the Production index(2004-2006) in Pakistan in 2006 to that in 2008?
Offer a very short reply. 0.91. What is the ratio of the Production index(2004-2006) of United Kingdom in 2006 to that in 2008?
Your response must be concise. 0.97. What is the ratio of the Production index(2004-2006) in Europe(all income levels) in 2007 to that in 2008?
Give a very brief answer. 0.96. What is the ratio of the Production index(2004-2006) of Argentina in 2007 to that in 2008?
Your response must be concise. 1.02. What is the ratio of the Production index(2004-2006) of Pakistan in 2007 to that in 2008?
Your answer should be compact. 0.96. What is the ratio of the Production index(2004-2006) in United Kingdom in 2007 to that in 2008?
Provide a succinct answer. 0.95. What is the difference between the highest and the second highest Production index(2004-2006) in Europe(all income levels)?
Your answer should be very brief. 2.79. What is the difference between the highest and the second highest Production index(2004-2006) of Argentina?
Provide a succinct answer. 2.79. What is the difference between the highest and the second highest Production index(2004-2006) in Pakistan?
Your answer should be compact. 4.79. What is the difference between the highest and the second highest Production index(2004-2006) of United Kingdom?
Give a very brief answer. 2.08. What is the difference between the highest and the lowest Production index(2004-2006) in Europe(all income levels)?
Make the answer very short. 7.8. What is the difference between the highest and the lowest Production index(2004-2006) in Argentina?
Your answer should be compact. 29.5. What is the difference between the highest and the lowest Production index(2004-2006) of Pakistan?
Offer a terse response. 24.95. What is the difference between the highest and the lowest Production index(2004-2006) in United Kingdom?
Ensure brevity in your answer.  5.07. 